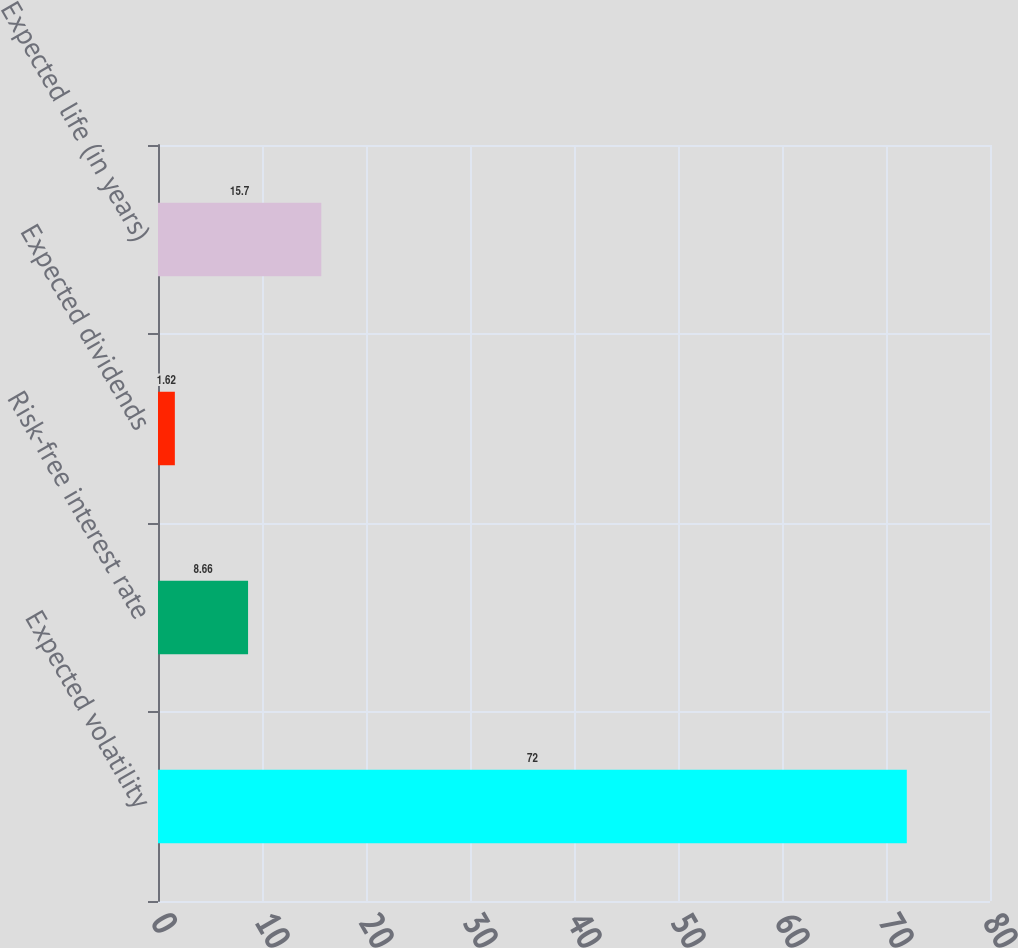Convert chart to OTSL. <chart><loc_0><loc_0><loc_500><loc_500><bar_chart><fcel>Expected volatility<fcel>Risk-free interest rate<fcel>Expected dividends<fcel>Expected life (in years)<nl><fcel>72<fcel>8.66<fcel>1.62<fcel>15.7<nl></chart> 